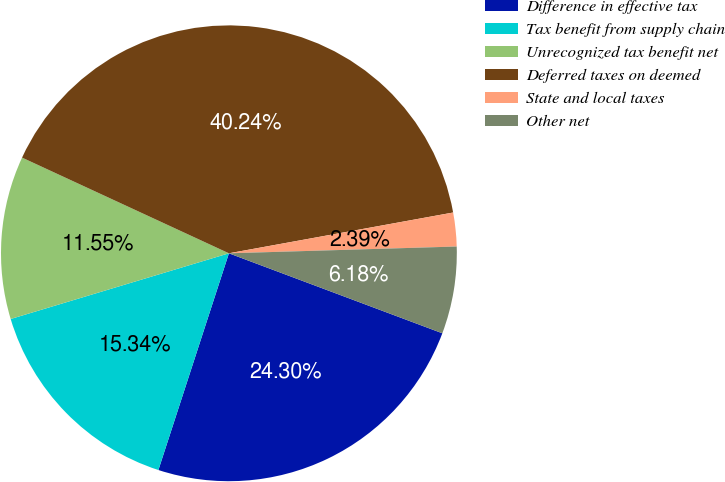Convert chart to OTSL. <chart><loc_0><loc_0><loc_500><loc_500><pie_chart><fcel>Difference in effective tax<fcel>Tax benefit from supply chain<fcel>Unrecognized tax benefit net<fcel>Deferred taxes on deemed<fcel>State and local taxes<fcel>Other net<nl><fcel>24.3%<fcel>15.34%<fcel>11.55%<fcel>40.24%<fcel>2.39%<fcel>6.18%<nl></chart> 